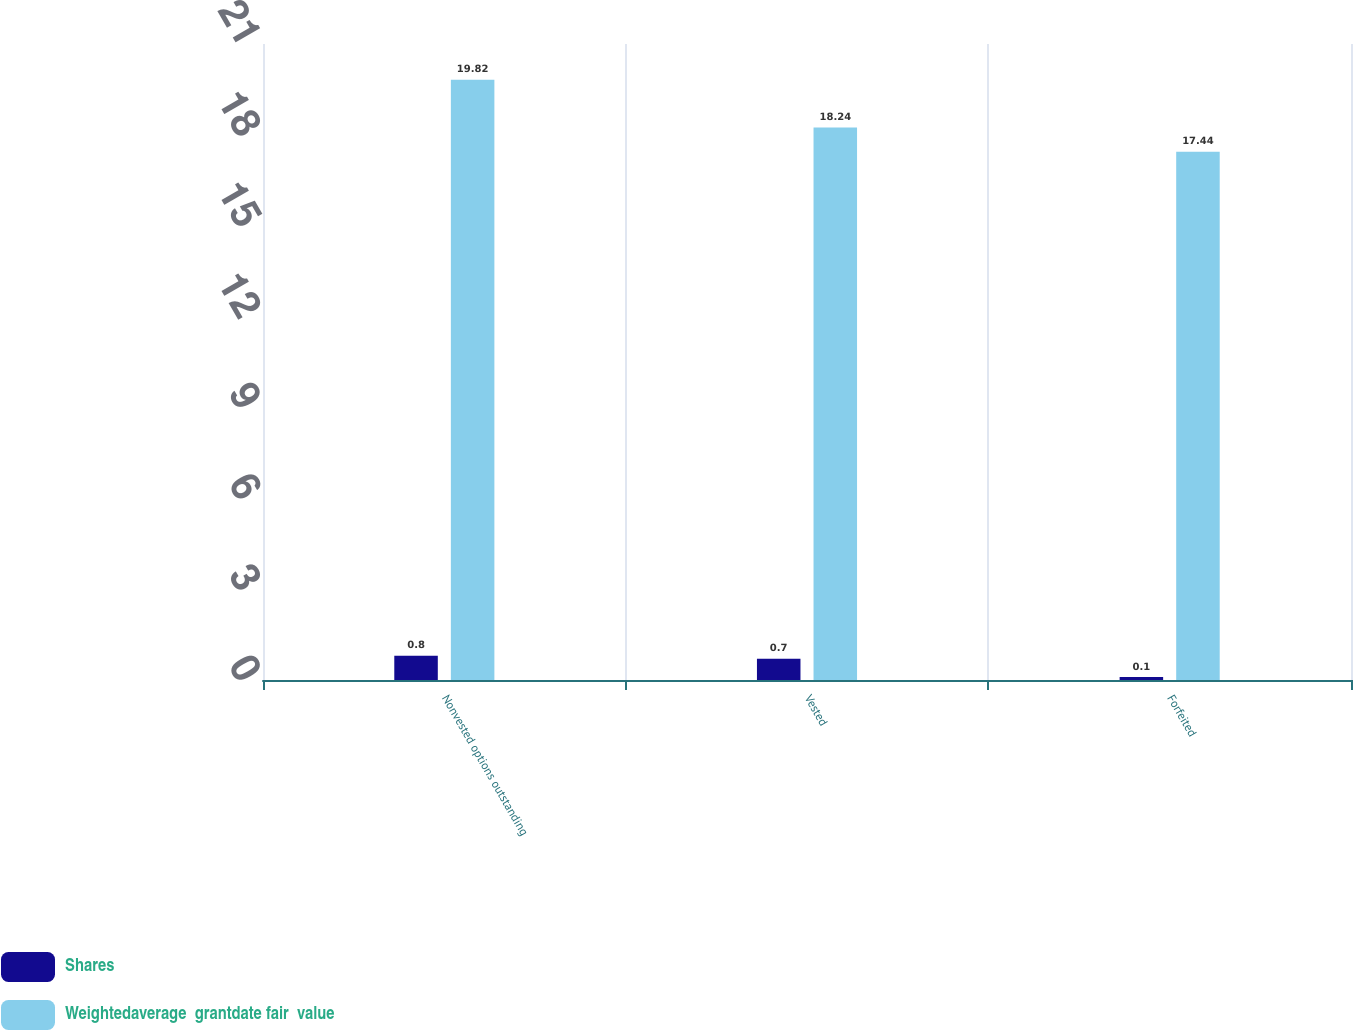<chart> <loc_0><loc_0><loc_500><loc_500><stacked_bar_chart><ecel><fcel>Nonvested options outstanding<fcel>Vested<fcel>Forfeited<nl><fcel>Shares<fcel>0.8<fcel>0.7<fcel>0.1<nl><fcel>Weightedaverage  grantdate fair  value<fcel>19.82<fcel>18.24<fcel>17.44<nl></chart> 